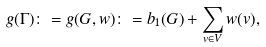Convert formula to latex. <formula><loc_0><loc_0><loc_500><loc_500>g ( \Gamma ) \colon = g ( G , w ) \colon = b _ { 1 } ( G ) + \sum _ { v \in V } w ( v ) ,</formula> 